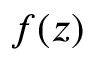<formula> <loc_0><loc_0><loc_500><loc_500>f ( z )</formula> 